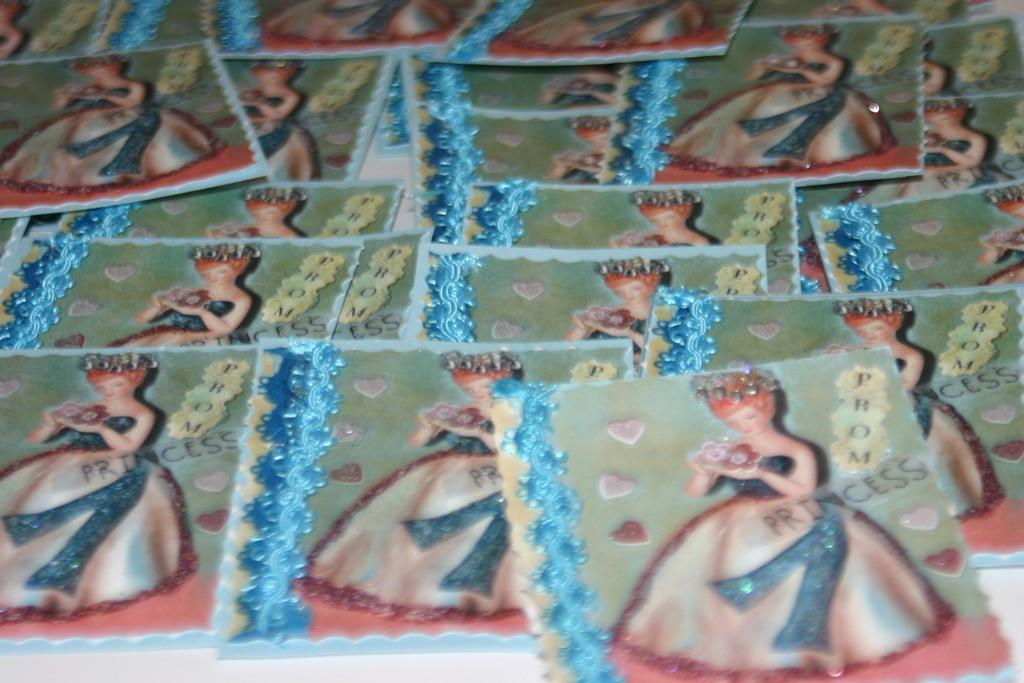What can be seen in the image? There are photos in the image. Can you describe the photos? Unfortunately, the details of the photos cannot be determined from the image alone. What type of cracker is being passed around in the crowd depicted in the image? There is no crowd or cracker present in the image; it only contains photos. 